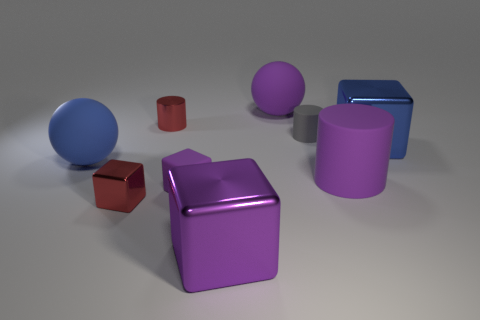Add 1 large purple blocks. How many objects exist? 10 Subtract all cylinders. How many objects are left? 6 Subtract 0 cyan cylinders. How many objects are left? 9 Subtract all tiny metal blocks. Subtract all large cylinders. How many objects are left? 7 Add 1 tiny red blocks. How many tiny red blocks are left? 2 Add 3 small gray rubber cylinders. How many small gray rubber cylinders exist? 4 